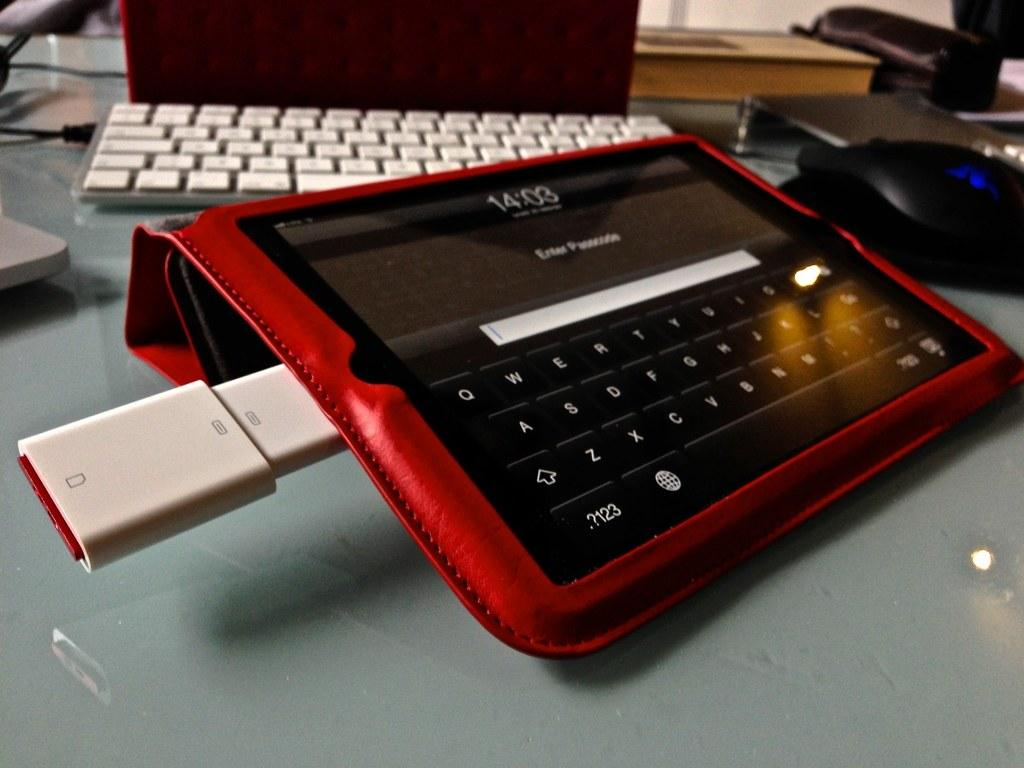What is the main object in the image? There is a gadget with a pen-drive inserted in the image. What is used for typing in the image? There is a keyboard in the image. What is used for controlling the cursor in the image? There is a mouse in the image. What type of quince is being used to power the gadget in the image? There is no quince present in the image; the gadget is powered by a pen-drive. How does the lamp in the image affect the brightness of the screen? There is no lamp present in the image. 